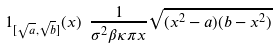Convert formula to latex. <formula><loc_0><loc_0><loc_500><loc_500>1 _ { [ \sqrt { a } , \sqrt { b } ] } ( x ) \ \frac { 1 } { \sigma ^ { 2 } \beta \kappa \pi x } \sqrt { ( x ^ { 2 } - a ) ( b - x ^ { 2 } ) }</formula> 